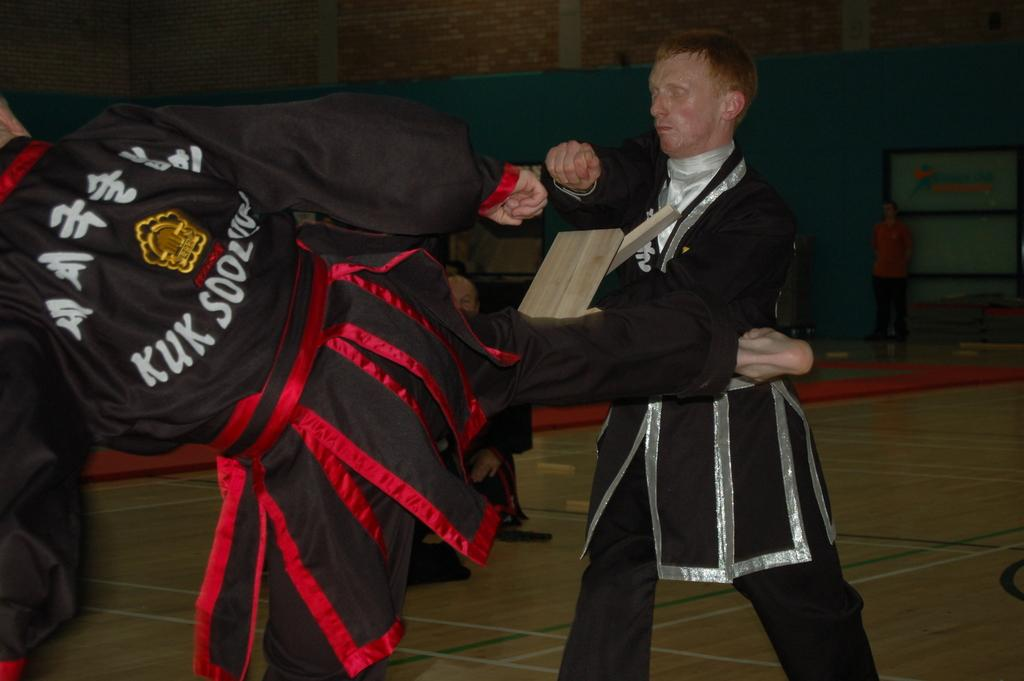<image>
Summarize the visual content of the image. a man kicking a person with kuk written on his back 